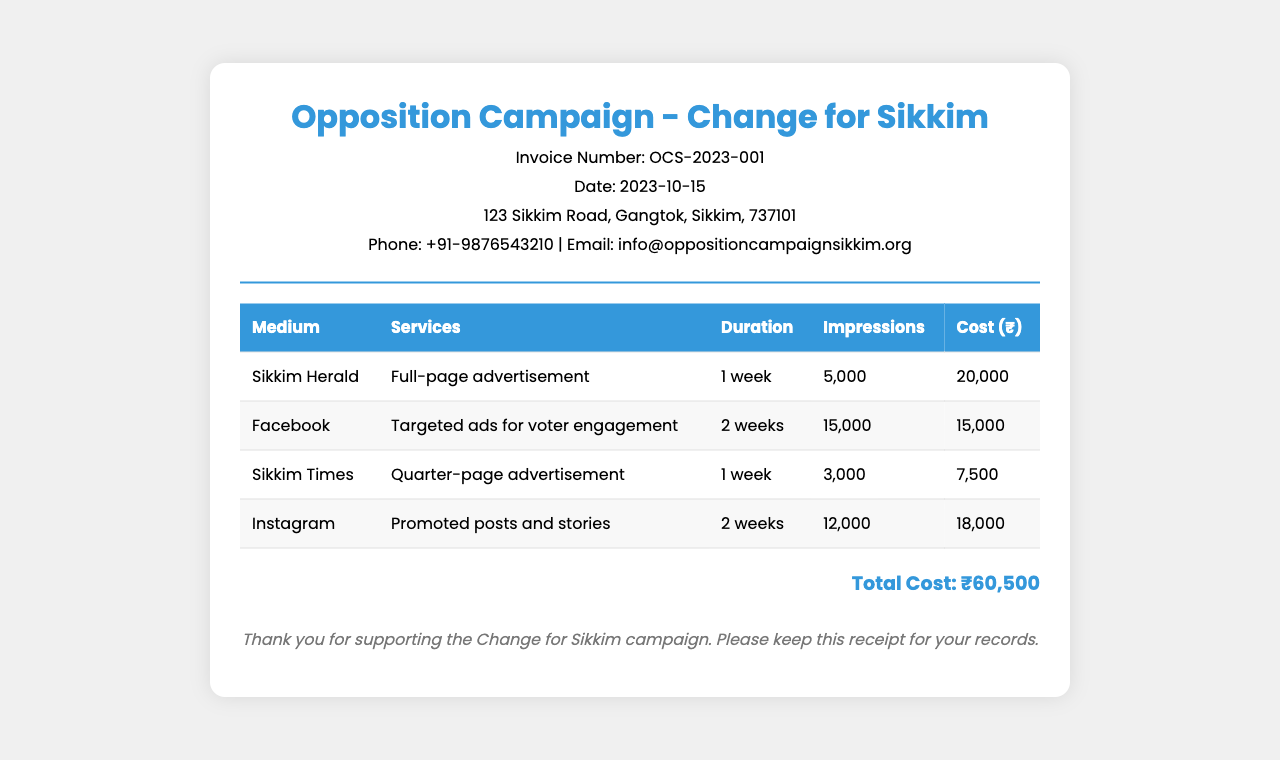What is the invoice number? The invoice number is explicitly mentioned at the top of the receipt.
Answer: OCS-2023-001 What is the total cost incurred? The total cost is clearly indicated at the bottom of the receipt.
Answer: ₹60,500 How many impressions were generated by the Facebook ads? The number of impressions for the Facebook ads is provided in the table detailing ad performance.
Answer: 15,000 What medium had the highest cost? By comparing the costs of each advertising medium listed, one can identify the highest.
Answer: Sikkim Herald How long did the Instagram promotional posts run? The duration for the Instagram ads is stated directly in the table.
Answer: 2 weeks Which newspaper was chosen for a quarter-page advertisement? The specific newspaper for the quarter-page ad is listed in the services provided.
Answer: Sikkim Times What service was provided for the Sikkim Herald? The service details for each medium are listed in the corresponding row of the table.
Answer: Full-page advertisement How many total impressions were generated? By summing all impressions listed for each advertising medium, we get the total.
Answer: 35,000 What was the duration for Sikkim Times advertising? The duration is specified in the table for each advertising entry.
Answer: 1 week 